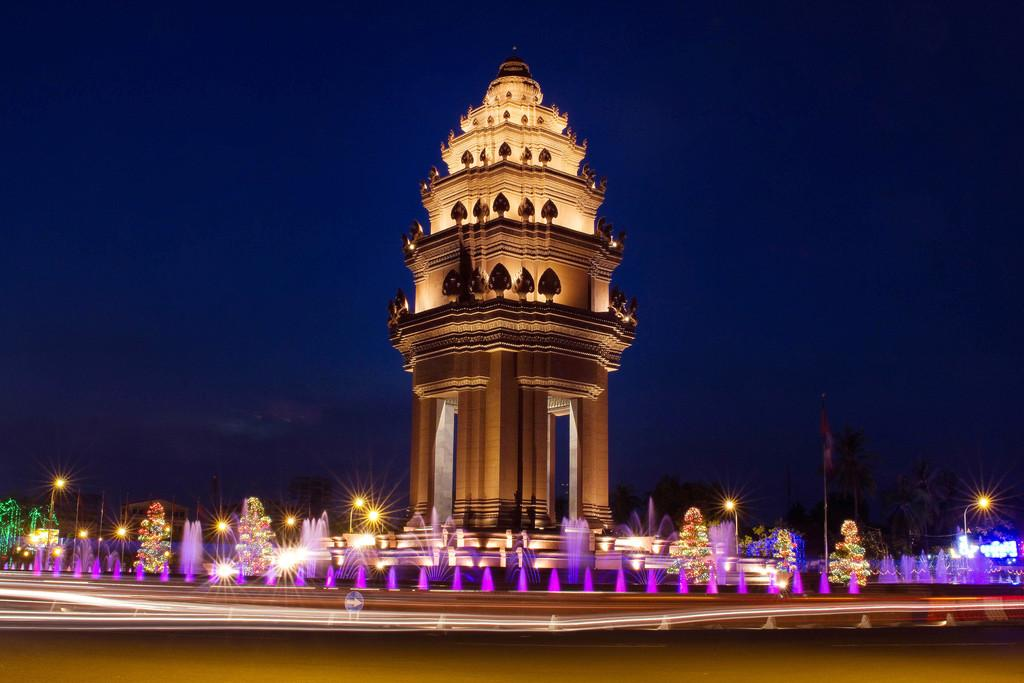What is the main structure in the image? There is a building in the image. What is located in front of the building? There are fountains in front of the building. What can be seen behind the building? There are trees visible behind the building. Can you tell me which actor is standing next to the fountain in the image? There are no actors present in the image; it features a building with fountains in front and trees behind. What type of horn can be seen on the building in the image? There is no horn present on the building in the image. 